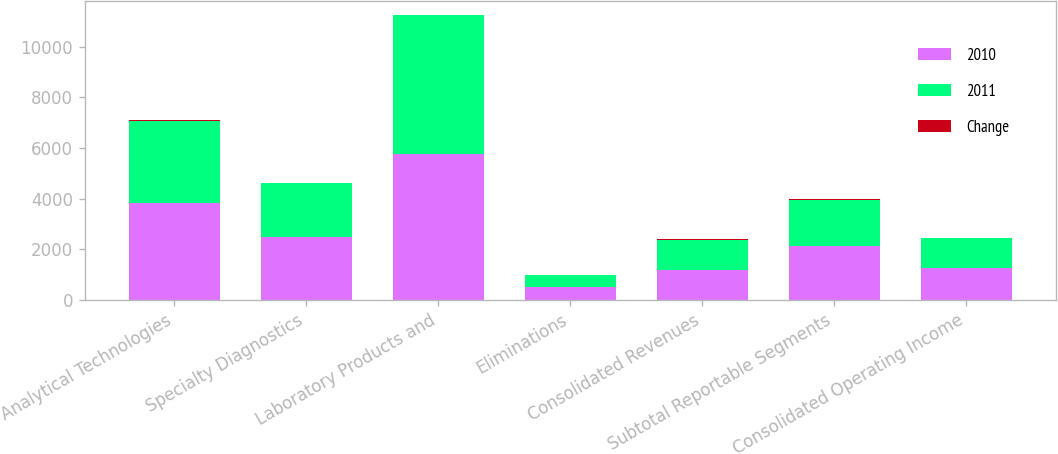Convert chart. <chart><loc_0><loc_0><loc_500><loc_500><stacked_bar_chart><ecel><fcel>Analytical Technologies<fcel>Specialty Diagnostics<fcel>Laboratory Products and<fcel>Eliminations<fcel>Consolidated Revenues<fcel>Subtotal Reportable Segments<fcel>Consolidated Operating Income<nl><fcel>2010<fcel>3845.4<fcel>2469.9<fcel>5762.9<fcel>519.4<fcel>1188.1<fcel>2129.3<fcel>1250.8<nl><fcel>2011<fcel>3238.2<fcel>2149<fcel>5473<fcel>467.1<fcel>1188.1<fcel>1819.2<fcel>1188.1<nl><fcel>Change<fcel>19<fcel>15<fcel>5<fcel>11<fcel>11<fcel>17<fcel>5<nl></chart> 